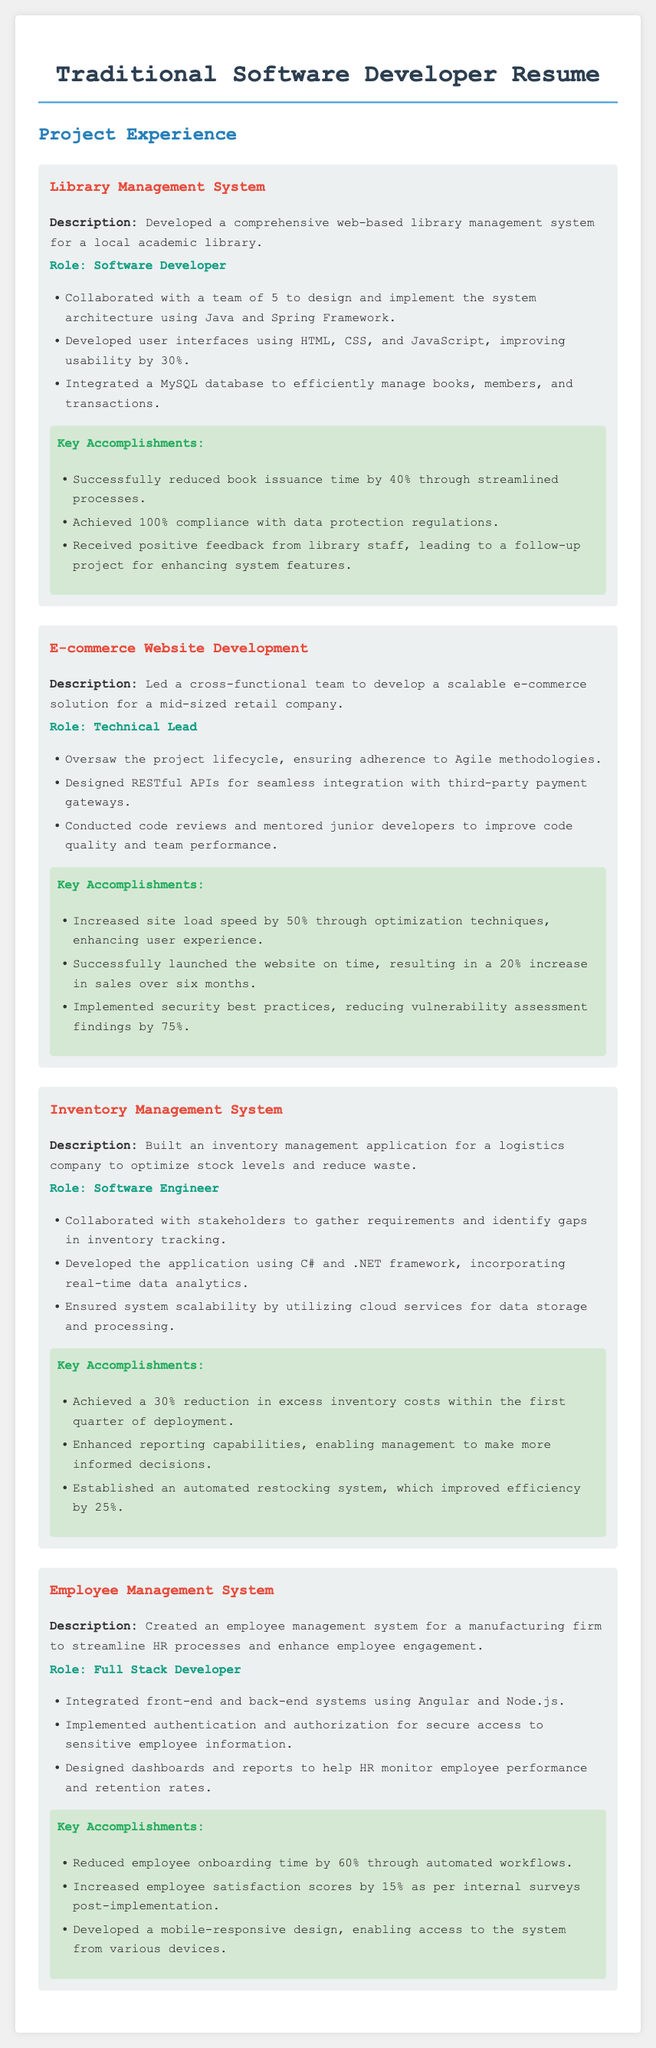What is the role of the person in the Library Management System project? The role is stated as "Software Developer" for the Library Management System project.
Answer: Software Developer How much did the book issuance time reduce by in the Library Management System? The accomplishment lists a reduction of 40% in book issuance time.
Answer: 40% What technology was used to develop the E-commerce Website? The document mentions that RESTful APIs were designed specifically for the E-commerce Website project.
Answer: RESTful APIs Which project led to a 20% increase in sales? The E-commerce Website Development project resulted in a 20% increase in sales after launch.
Answer: E-commerce Website Development What accomplishment improved employee satisfaction scores by 15%? The implementation of the Employee Management System helped increase employee satisfaction scores by 15%.
Answer: Employee Management System What programming language was used in the Inventory Management System? It is stated that C# was used in the development of the Inventory Management System.
Answer: C# How many projects are listed in the experience section? The document provides a total of four projects in the Project Experience section.
Answer: Four What role did the person take in the Employee Management System project? The role is specified as "Full Stack Developer" for the Employee Management System project.
Answer: Full Stack Developer What was a key accomplishment of the Inventory Management System? A key accomplishment listed is a 30% reduction in excess inventory costs within the first quarter.
Answer: 30% reduction in excess inventory costs 